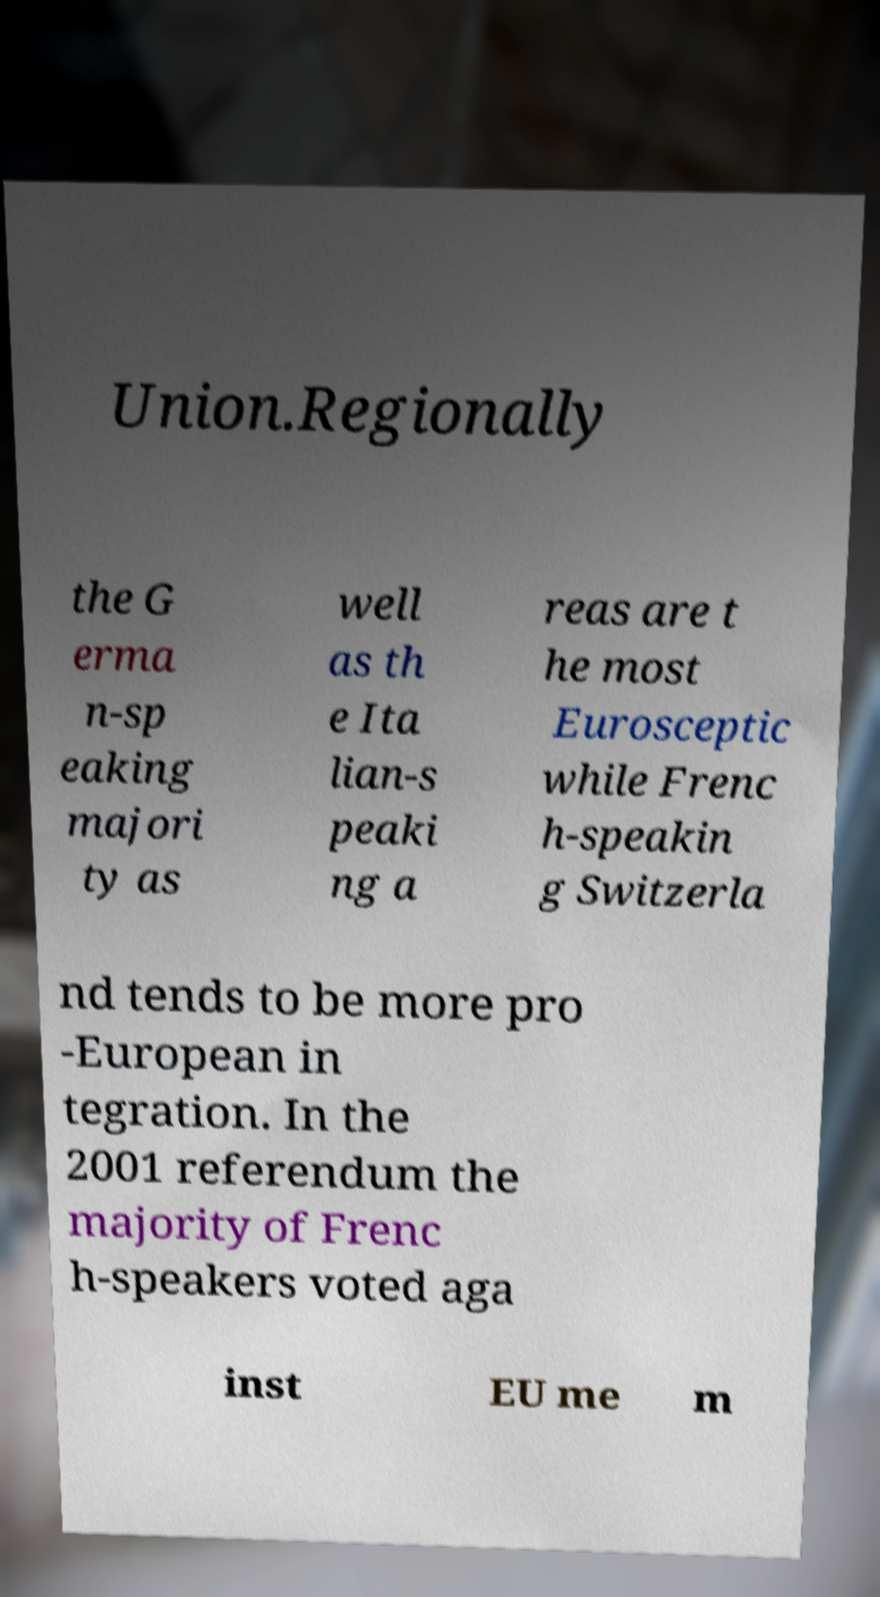Can you read and provide the text displayed in the image?This photo seems to have some interesting text. Can you extract and type it out for me? Union.Regionally the G erma n-sp eaking majori ty as well as th e Ita lian-s peaki ng a reas are t he most Eurosceptic while Frenc h-speakin g Switzerla nd tends to be more pro -European in tegration. In the 2001 referendum the majority of Frenc h-speakers voted aga inst EU me m 